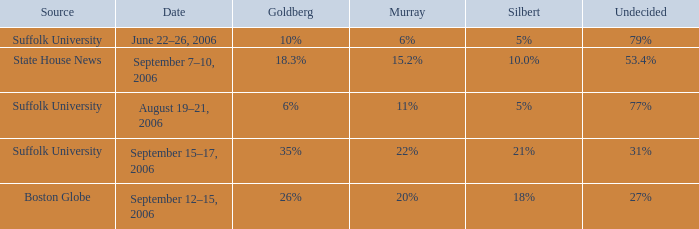What is the date of the poll with Silbert at 18%? September 12–15, 2006. 